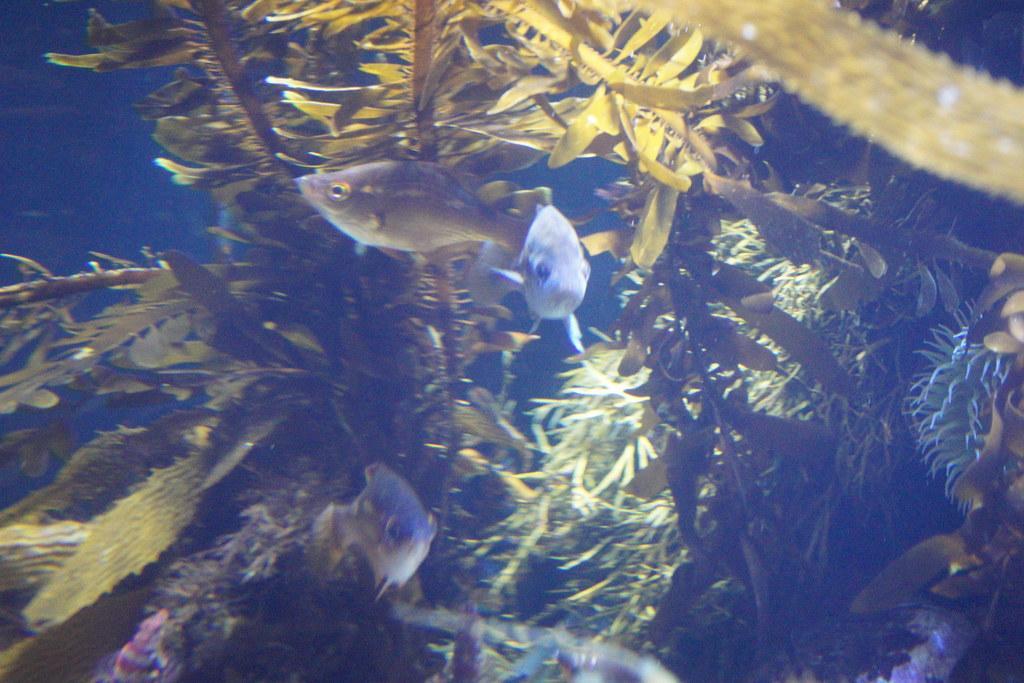In one or two sentences, can you explain what this image depicts? In this image there are few fishes in water. Behind the fishes there are few plants. 